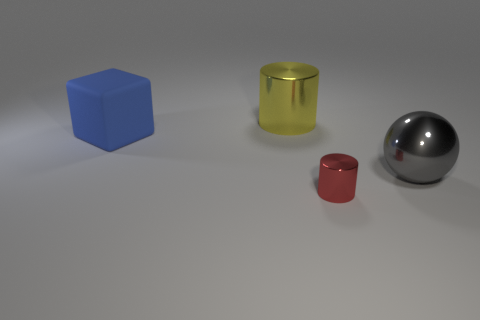Subtract all cubes. How many objects are left? 3 Add 3 large blue blocks. How many objects exist? 7 Subtract 1 cylinders. How many cylinders are left? 1 Subtract all red cylinders. Subtract all tiny gray spheres. How many objects are left? 3 Add 1 cylinders. How many cylinders are left? 3 Add 3 large yellow objects. How many large yellow objects exist? 4 Subtract 0 yellow blocks. How many objects are left? 4 Subtract all green spheres. Subtract all cyan blocks. How many spheres are left? 1 Subtract all blue balls. How many yellow cubes are left? 0 